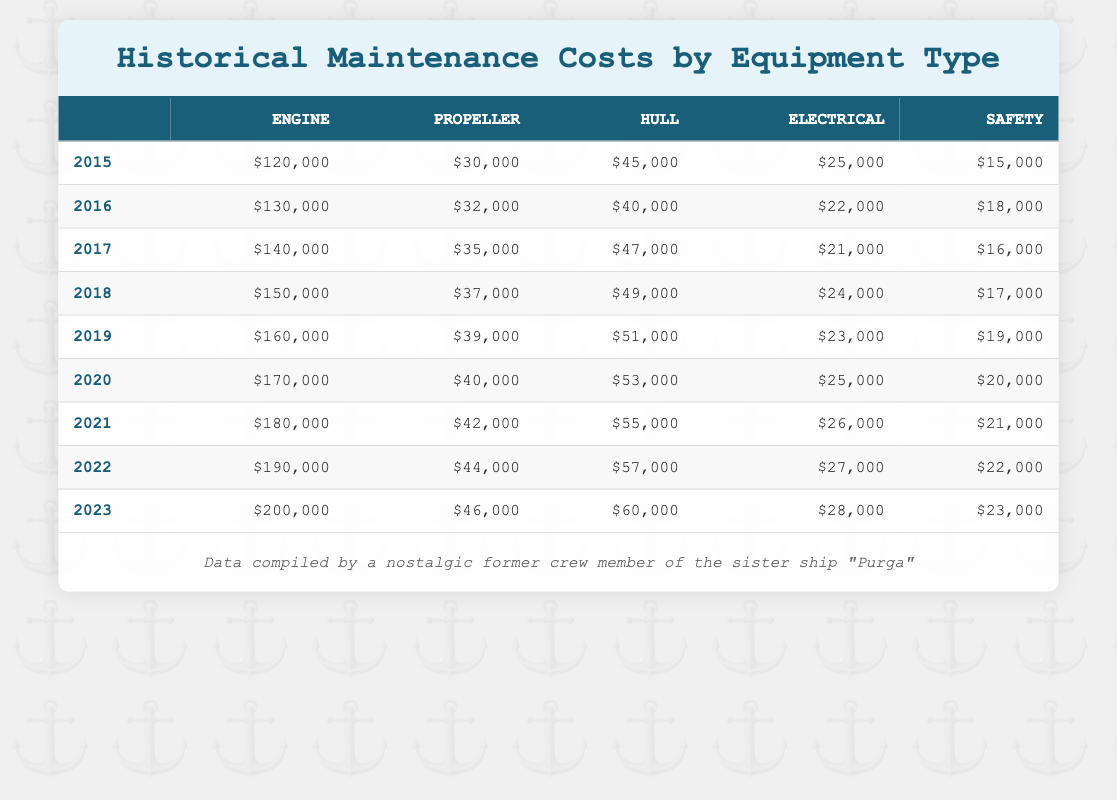What is the maintenance cost for the Hull in 2020? Looking at the row for the year 2020, the cost for Hull is clearly listed as $53,000.
Answer: $53,000 Which equipment type had the highest maintenance cost in 2023? In 2023, the Engine has the highest cost listed at $200,000, while the other equipment types have lower costs.
Answer: Engine What was the total maintenance cost for Electrical equipment from 2015 to 2023? Summing the Electrical costs from 2015 to 2023 gives: 25000 + 22000 + 21000 + 24000 + 23000 + 25000 + 26000 + 27000 + 28000 = 199000.
Answer: $199,000 Did the Safety costs increase every year from 2015 to 2023? Looking at the Safety costs year by year, they are: 15000, 18000, 16000, 17000, 19000, 20000, 21000, 22000, 23000; there was a decrease from 2015 to 2016 and from 2016 to 2017. Therefore, the costs did not increase every year.
Answer: No What is the average cost of the Propeller maintenance from 2015 to 2023? The Propeller costs are: 30000, 32000, 35000, 37000, 39000, 40000, 42000, 44000, 46000. Adding these gives 3,490,000, and dividing by the number of years (9) gives an average of 387,777.78.
Answer: $38,778 What equipment type consistently had the lowest maintenance cost during 2015 to 2023? Reviewing each year, the Safety costs were consistently the lowest compared to the other types. In every year listed, the Safety costs are lower than Engine, Hull, Electrical, and Propeller.
Answer: Safety What was the percentage increase in Engine maintenance costs from 2015 to 2023? The Engine cost in 2015 was $120,000 and in 2023 it was $200,000. The increase is 200000 - 120000 = 80000. The percentage increase is (80000/120000) * 100, which equals 66.67%.
Answer: 66.67% In which year did the Hull maintenance costs first exceed $50,000? Tracking the Hull costs: 45000 (2015), 40000 (2016), 47000 (2017), 49000 (2018), 51000 (2019), 53000 (2020), 55000 (2021), 57000 (2022), 60000 (2023), we see that $50,000 was first exceeded in 2019.
Answer: 2019 